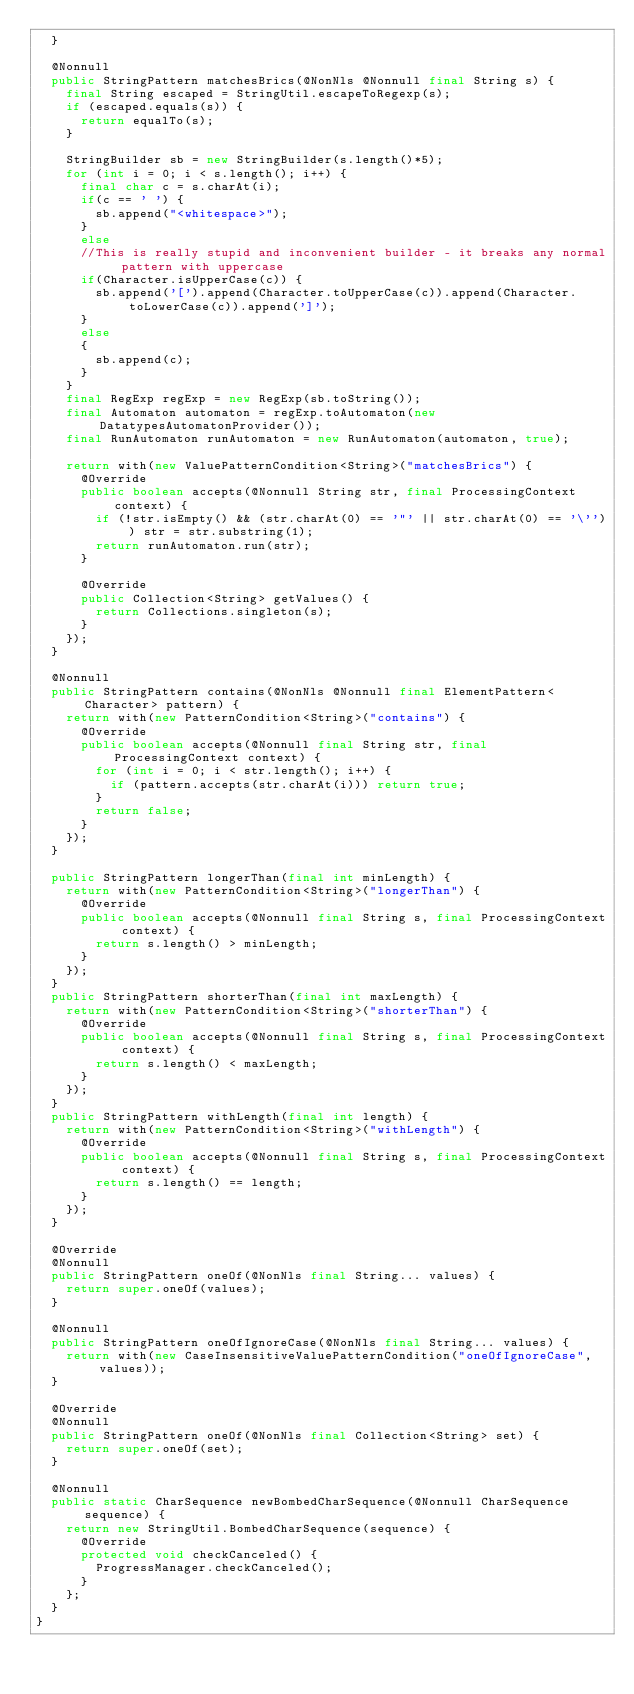<code> <loc_0><loc_0><loc_500><loc_500><_Java_>  }

  @Nonnull
  public StringPattern matchesBrics(@NonNls @Nonnull final String s) {
    final String escaped = StringUtil.escapeToRegexp(s);
    if (escaped.equals(s)) {
      return equalTo(s);
    }

    StringBuilder sb = new StringBuilder(s.length()*5);
    for (int i = 0; i < s.length(); i++) {
      final char c = s.charAt(i);
      if(c == ' ') {
        sb.append("<whitespace>");
      }
      else
      //This is really stupid and inconvenient builder - it breaks any normal pattern with uppercase
      if(Character.isUpperCase(c)) {
        sb.append('[').append(Character.toUpperCase(c)).append(Character.toLowerCase(c)).append(']');
      }
      else
      {
        sb.append(c);
      }
    }
    final RegExp regExp = new RegExp(sb.toString());
    final Automaton automaton = regExp.toAutomaton(new DatatypesAutomatonProvider());
    final RunAutomaton runAutomaton = new RunAutomaton(automaton, true);

    return with(new ValuePatternCondition<String>("matchesBrics") {
      @Override
      public boolean accepts(@Nonnull String str, final ProcessingContext context) {
        if (!str.isEmpty() && (str.charAt(0) == '"' || str.charAt(0) == '\'')) str = str.substring(1);
        return runAutomaton.run(str);
      }

      @Override
      public Collection<String> getValues() {
        return Collections.singleton(s);
      }
    });
  }

  @Nonnull
  public StringPattern contains(@NonNls @Nonnull final ElementPattern<Character> pattern) {
    return with(new PatternCondition<String>("contains") {
      @Override
      public boolean accepts(@Nonnull final String str, final ProcessingContext context) {
        for (int i = 0; i < str.length(); i++) {
          if (pattern.accepts(str.charAt(i))) return true;
        }
        return false;
      }
    });
  }

  public StringPattern longerThan(final int minLength) {
    return with(new PatternCondition<String>("longerThan") {
      @Override
      public boolean accepts(@Nonnull final String s, final ProcessingContext context) {
        return s.length() > minLength;
      }
    });
  }
  public StringPattern shorterThan(final int maxLength) {
    return with(new PatternCondition<String>("shorterThan") {
      @Override
      public boolean accepts(@Nonnull final String s, final ProcessingContext context) {
        return s.length() < maxLength;
      }
    });
  }
  public StringPattern withLength(final int length) {
    return with(new PatternCondition<String>("withLength") {
      @Override
      public boolean accepts(@Nonnull final String s, final ProcessingContext context) {
        return s.length() == length;
      }
    });
  }

  @Override
  @Nonnull
  public StringPattern oneOf(@NonNls final String... values) {
    return super.oneOf(values);
  }

  @Nonnull
  public StringPattern oneOfIgnoreCase(@NonNls final String... values) {
    return with(new CaseInsensitiveValuePatternCondition("oneOfIgnoreCase", values));
  }

  @Override
  @Nonnull
  public StringPattern oneOf(@NonNls final Collection<String> set) {
    return super.oneOf(set);
  }

  @Nonnull
  public static CharSequence newBombedCharSequence(@Nonnull CharSequence sequence) {
    return new StringUtil.BombedCharSequence(sequence) {
      @Override
      protected void checkCanceled() {
        ProgressManager.checkCanceled();
      }
    };
  }
}
</code> 